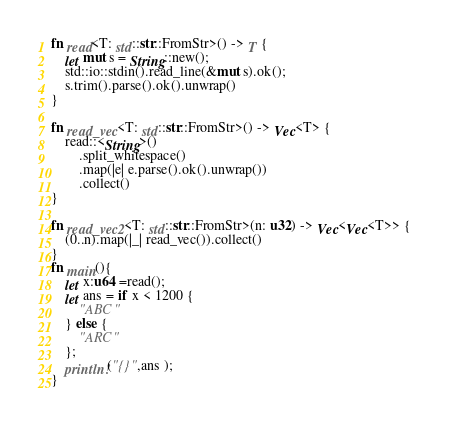Convert code to text. <code><loc_0><loc_0><loc_500><loc_500><_Rust_>fn read<T: std::str::FromStr>() -> T {
    let mut s = String::new();
    std::io::stdin().read_line(&mut s).ok();
    s.trim().parse().ok().unwrap()
}

fn read_vec<T: std::str::FromStr>() -> Vec<T> {
    read::<String>()
        .split_whitespace()
        .map(|e| e.parse().ok().unwrap())
        .collect()
}

fn read_vec2<T: std::str::FromStr>(n: u32) -> Vec<Vec<T>> {
    (0..n).map(|_| read_vec()).collect()
}
fn main(){
    let x:u64 =read();
    let ans = if x < 1200 {
        "ABC"
    } else {
        "ARC"
    };
    println!("{}",ans );
}</code> 